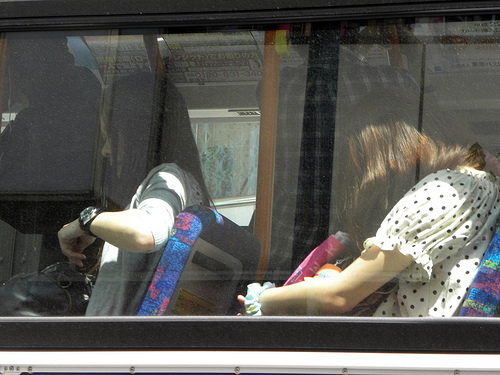<image>
Is the watch in the bus? Yes. The watch is contained within or inside the bus, showing a containment relationship. Where is the woman in relation to the window? Is it behind the window? Yes. From this viewpoint, the woman is positioned behind the window, with the window partially or fully occluding the woman. 